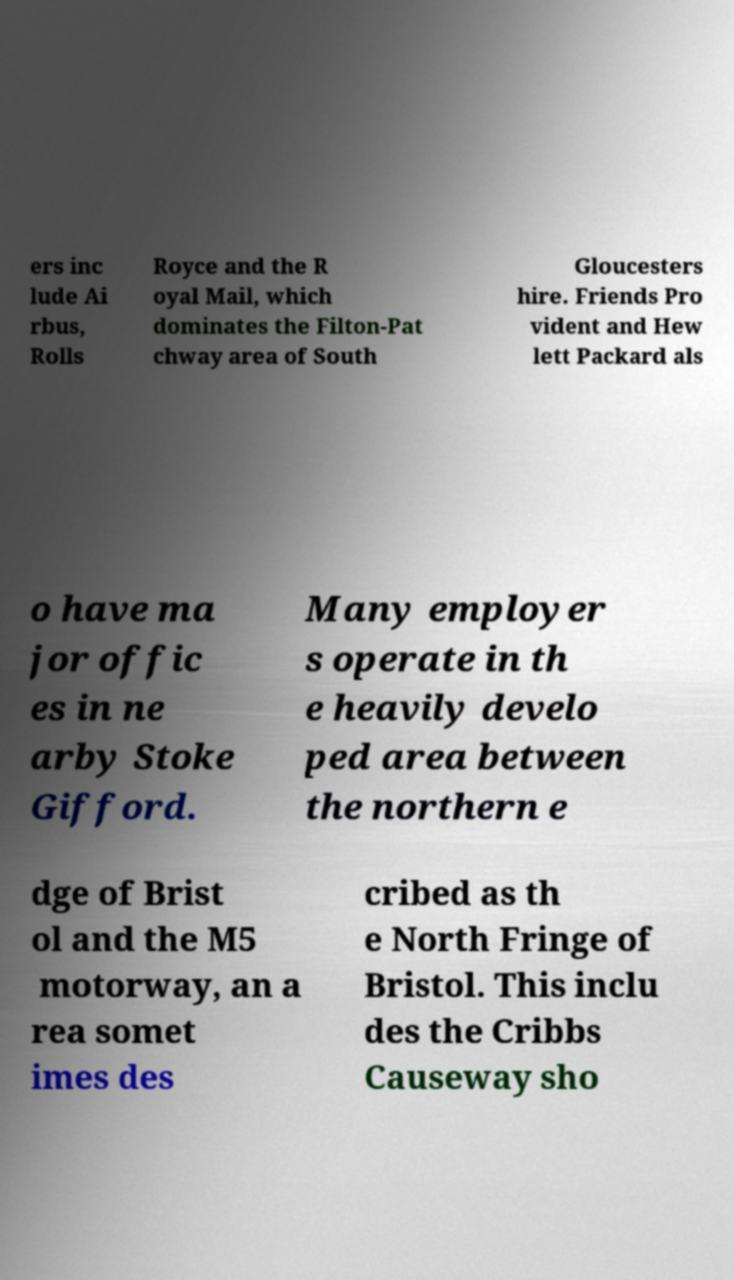Please read and relay the text visible in this image. What does it say? ers inc lude Ai rbus, Rolls Royce and the R oyal Mail, which dominates the Filton-Pat chway area of South Gloucesters hire. Friends Pro vident and Hew lett Packard als o have ma jor offic es in ne arby Stoke Gifford. Many employer s operate in th e heavily develo ped area between the northern e dge of Brist ol and the M5 motorway, an a rea somet imes des cribed as th e North Fringe of Bristol. This inclu des the Cribbs Causeway sho 